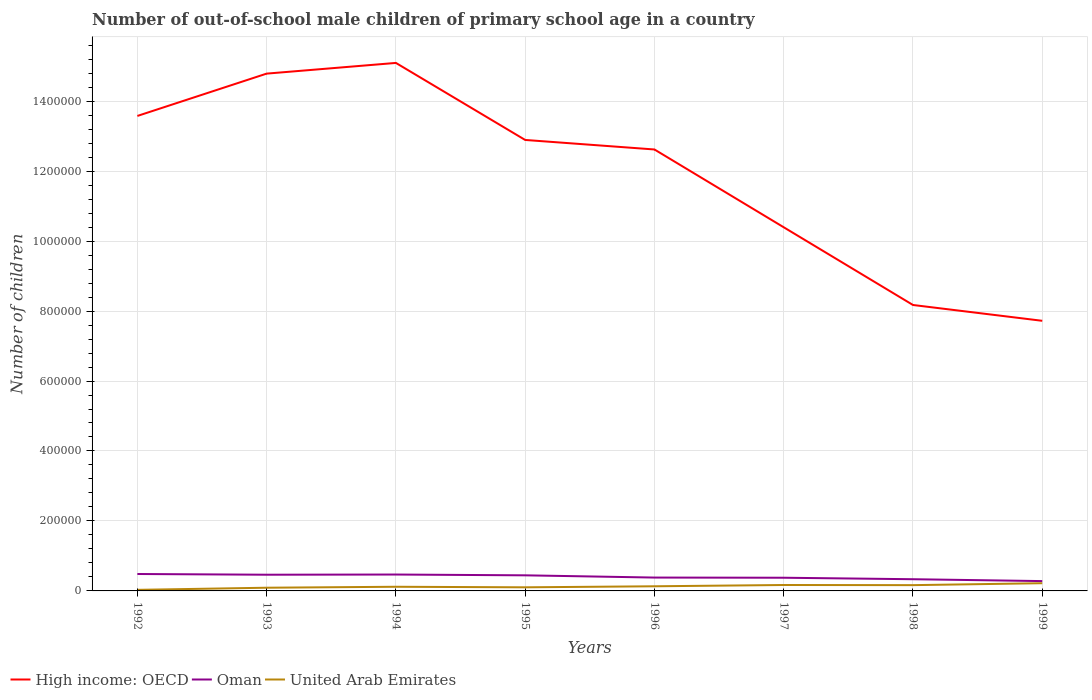How many different coloured lines are there?
Keep it short and to the point. 3. Across all years, what is the maximum number of out-of-school male children in United Arab Emirates?
Keep it short and to the point. 3090. In which year was the number of out-of-school male children in Oman maximum?
Keep it short and to the point. 1999. What is the total number of out-of-school male children in Oman in the graph?
Your response must be concise. -550. What is the difference between the highest and the second highest number of out-of-school male children in High income: OECD?
Offer a terse response. 7.37e+05. What is the difference between the highest and the lowest number of out-of-school male children in High income: OECD?
Your answer should be compact. 5. How many lines are there?
Keep it short and to the point. 3. How many years are there in the graph?
Ensure brevity in your answer.  8. What is the difference between two consecutive major ticks on the Y-axis?
Your answer should be compact. 2.00e+05. Are the values on the major ticks of Y-axis written in scientific E-notation?
Your answer should be compact. No. Where does the legend appear in the graph?
Provide a succinct answer. Bottom left. How many legend labels are there?
Offer a terse response. 3. What is the title of the graph?
Make the answer very short. Number of out-of-school male children of primary school age in a country. What is the label or title of the X-axis?
Your answer should be very brief. Years. What is the label or title of the Y-axis?
Offer a very short reply. Number of children. What is the Number of children of High income: OECD in 1992?
Your response must be concise. 1.36e+06. What is the Number of children of Oman in 1992?
Offer a very short reply. 4.84e+04. What is the Number of children in United Arab Emirates in 1992?
Provide a short and direct response. 3090. What is the Number of children in High income: OECD in 1993?
Offer a very short reply. 1.48e+06. What is the Number of children in Oman in 1993?
Ensure brevity in your answer.  4.63e+04. What is the Number of children of United Arab Emirates in 1993?
Your response must be concise. 9153. What is the Number of children of High income: OECD in 1994?
Give a very brief answer. 1.51e+06. What is the Number of children in Oman in 1994?
Keep it short and to the point. 4.69e+04. What is the Number of children in United Arab Emirates in 1994?
Provide a succinct answer. 1.19e+04. What is the Number of children in High income: OECD in 1995?
Your response must be concise. 1.29e+06. What is the Number of children of Oman in 1995?
Your answer should be compact. 4.46e+04. What is the Number of children of United Arab Emirates in 1995?
Keep it short and to the point. 1.03e+04. What is the Number of children in High income: OECD in 1996?
Offer a terse response. 1.26e+06. What is the Number of children in Oman in 1996?
Keep it short and to the point. 3.82e+04. What is the Number of children of United Arab Emirates in 1996?
Offer a terse response. 1.33e+04. What is the Number of children in High income: OECD in 1997?
Ensure brevity in your answer.  1.04e+06. What is the Number of children of Oman in 1997?
Provide a short and direct response. 3.77e+04. What is the Number of children of United Arab Emirates in 1997?
Your response must be concise. 1.69e+04. What is the Number of children of High income: OECD in 1998?
Provide a short and direct response. 8.17e+05. What is the Number of children in Oman in 1998?
Make the answer very short. 3.35e+04. What is the Number of children in United Arab Emirates in 1998?
Give a very brief answer. 1.65e+04. What is the Number of children of High income: OECD in 1999?
Provide a succinct answer. 7.72e+05. What is the Number of children in Oman in 1999?
Ensure brevity in your answer.  2.81e+04. What is the Number of children in United Arab Emirates in 1999?
Make the answer very short. 2.21e+04. Across all years, what is the maximum Number of children in High income: OECD?
Your answer should be compact. 1.51e+06. Across all years, what is the maximum Number of children of Oman?
Offer a terse response. 4.84e+04. Across all years, what is the maximum Number of children of United Arab Emirates?
Offer a very short reply. 2.21e+04. Across all years, what is the minimum Number of children of High income: OECD?
Ensure brevity in your answer.  7.72e+05. Across all years, what is the minimum Number of children in Oman?
Give a very brief answer. 2.81e+04. Across all years, what is the minimum Number of children of United Arab Emirates?
Your answer should be very brief. 3090. What is the total Number of children in High income: OECD in the graph?
Your answer should be very brief. 9.53e+06. What is the total Number of children in Oman in the graph?
Provide a short and direct response. 3.24e+05. What is the total Number of children of United Arab Emirates in the graph?
Give a very brief answer. 1.03e+05. What is the difference between the Number of children of High income: OECD in 1992 and that in 1993?
Provide a short and direct response. -1.21e+05. What is the difference between the Number of children in Oman in 1992 and that in 1993?
Ensure brevity in your answer.  2030. What is the difference between the Number of children of United Arab Emirates in 1992 and that in 1993?
Your answer should be compact. -6063. What is the difference between the Number of children in High income: OECD in 1992 and that in 1994?
Your response must be concise. -1.52e+05. What is the difference between the Number of children in Oman in 1992 and that in 1994?
Make the answer very short. 1480. What is the difference between the Number of children of United Arab Emirates in 1992 and that in 1994?
Your response must be concise. -8775. What is the difference between the Number of children of High income: OECD in 1992 and that in 1995?
Your answer should be very brief. 6.86e+04. What is the difference between the Number of children of Oman in 1992 and that in 1995?
Offer a terse response. 3775. What is the difference between the Number of children in United Arab Emirates in 1992 and that in 1995?
Provide a succinct answer. -7204. What is the difference between the Number of children in High income: OECD in 1992 and that in 1996?
Provide a short and direct response. 9.58e+04. What is the difference between the Number of children of Oman in 1992 and that in 1996?
Provide a short and direct response. 1.02e+04. What is the difference between the Number of children in United Arab Emirates in 1992 and that in 1996?
Your answer should be compact. -1.02e+04. What is the difference between the Number of children in High income: OECD in 1992 and that in 1997?
Your answer should be very brief. 3.18e+05. What is the difference between the Number of children in Oman in 1992 and that in 1997?
Your answer should be compact. 1.06e+04. What is the difference between the Number of children of United Arab Emirates in 1992 and that in 1997?
Make the answer very short. -1.38e+04. What is the difference between the Number of children in High income: OECD in 1992 and that in 1998?
Your response must be concise. 5.40e+05. What is the difference between the Number of children of Oman in 1992 and that in 1998?
Give a very brief answer. 1.49e+04. What is the difference between the Number of children in United Arab Emirates in 1992 and that in 1998?
Keep it short and to the point. -1.34e+04. What is the difference between the Number of children in High income: OECD in 1992 and that in 1999?
Give a very brief answer. 5.86e+05. What is the difference between the Number of children in Oman in 1992 and that in 1999?
Make the answer very short. 2.03e+04. What is the difference between the Number of children in United Arab Emirates in 1992 and that in 1999?
Your answer should be compact. -1.90e+04. What is the difference between the Number of children of High income: OECD in 1993 and that in 1994?
Your answer should be compact. -3.06e+04. What is the difference between the Number of children in Oman in 1993 and that in 1994?
Your response must be concise. -550. What is the difference between the Number of children in United Arab Emirates in 1993 and that in 1994?
Provide a short and direct response. -2712. What is the difference between the Number of children of High income: OECD in 1993 and that in 1995?
Your answer should be compact. 1.90e+05. What is the difference between the Number of children of Oman in 1993 and that in 1995?
Give a very brief answer. 1745. What is the difference between the Number of children of United Arab Emirates in 1993 and that in 1995?
Offer a very short reply. -1141. What is the difference between the Number of children in High income: OECD in 1993 and that in 1996?
Ensure brevity in your answer.  2.17e+05. What is the difference between the Number of children in Oman in 1993 and that in 1996?
Your answer should be compact. 8154. What is the difference between the Number of children of United Arab Emirates in 1993 and that in 1996?
Provide a short and direct response. -4112. What is the difference between the Number of children in High income: OECD in 1993 and that in 1997?
Give a very brief answer. 4.39e+05. What is the difference between the Number of children in Oman in 1993 and that in 1997?
Your response must be concise. 8606. What is the difference between the Number of children of United Arab Emirates in 1993 and that in 1997?
Your answer should be compact. -7762. What is the difference between the Number of children in High income: OECD in 1993 and that in 1998?
Make the answer very short. 6.61e+05. What is the difference between the Number of children in Oman in 1993 and that in 1998?
Ensure brevity in your answer.  1.29e+04. What is the difference between the Number of children in United Arab Emirates in 1993 and that in 1998?
Keep it short and to the point. -7359. What is the difference between the Number of children in High income: OECD in 1993 and that in 1999?
Provide a short and direct response. 7.07e+05. What is the difference between the Number of children of Oman in 1993 and that in 1999?
Ensure brevity in your answer.  1.82e+04. What is the difference between the Number of children of United Arab Emirates in 1993 and that in 1999?
Your response must be concise. -1.29e+04. What is the difference between the Number of children in High income: OECD in 1994 and that in 1995?
Provide a succinct answer. 2.20e+05. What is the difference between the Number of children in Oman in 1994 and that in 1995?
Provide a short and direct response. 2295. What is the difference between the Number of children in United Arab Emirates in 1994 and that in 1995?
Your answer should be compact. 1571. What is the difference between the Number of children in High income: OECD in 1994 and that in 1996?
Offer a terse response. 2.47e+05. What is the difference between the Number of children of Oman in 1994 and that in 1996?
Offer a terse response. 8704. What is the difference between the Number of children of United Arab Emirates in 1994 and that in 1996?
Your answer should be very brief. -1400. What is the difference between the Number of children in High income: OECD in 1994 and that in 1997?
Give a very brief answer. 4.70e+05. What is the difference between the Number of children in Oman in 1994 and that in 1997?
Offer a very short reply. 9156. What is the difference between the Number of children of United Arab Emirates in 1994 and that in 1997?
Give a very brief answer. -5050. What is the difference between the Number of children in High income: OECD in 1994 and that in 1998?
Offer a very short reply. 6.92e+05. What is the difference between the Number of children of Oman in 1994 and that in 1998?
Make the answer very short. 1.34e+04. What is the difference between the Number of children in United Arab Emirates in 1994 and that in 1998?
Provide a succinct answer. -4647. What is the difference between the Number of children of High income: OECD in 1994 and that in 1999?
Make the answer very short. 7.37e+05. What is the difference between the Number of children of Oman in 1994 and that in 1999?
Make the answer very short. 1.88e+04. What is the difference between the Number of children in United Arab Emirates in 1994 and that in 1999?
Provide a succinct answer. -1.02e+04. What is the difference between the Number of children of High income: OECD in 1995 and that in 1996?
Ensure brevity in your answer.  2.72e+04. What is the difference between the Number of children in Oman in 1995 and that in 1996?
Provide a succinct answer. 6409. What is the difference between the Number of children of United Arab Emirates in 1995 and that in 1996?
Keep it short and to the point. -2971. What is the difference between the Number of children in High income: OECD in 1995 and that in 1997?
Make the answer very short. 2.50e+05. What is the difference between the Number of children of Oman in 1995 and that in 1997?
Your answer should be very brief. 6861. What is the difference between the Number of children of United Arab Emirates in 1995 and that in 1997?
Provide a succinct answer. -6621. What is the difference between the Number of children in High income: OECD in 1995 and that in 1998?
Your answer should be compact. 4.72e+05. What is the difference between the Number of children of Oman in 1995 and that in 1998?
Your answer should be compact. 1.11e+04. What is the difference between the Number of children in United Arab Emirates in 1995 and that in 1998?
Keep it short and to the point. -6218. What is the difference between the Number of children of High income: OECD in 1995 and that in 1999?
Keep it short and to the point. 5.17e+05. What is the difference between the Number of children in Oman in 1995 and that in 1999?
Provide a succinct answer. 1.65e+04. What is the difference between the Number of children in United Arab Emirates in 1995 and that in 1999?
Make the answer very short. -1.18e+04. What is the difference between the Number of children of High income: OECD in 1996 and that in 1997?
Your answer should be compact. 2.22e+05. What is the difference between the Number of children in Oman in 1996 and that in 1997?
Make the answer very short. 452. What is the difference between the Number of children in United Arab Emirates in 1996 and that in 1997?
Offer a very short reply. -3650. What is the difference between the Number of children of High income: OECD in 1996 and that in 1998?
Provide a short and direct response. 4.45e+05. What is the difference between the Number of children of Oman in 1996 and that in 1998?
Make the answer very short. 4708. What is the difference between the Number of children in United Arab Emirates in 1996 and that in 1998?
Give a very brief answer. -3247. What is the difference between the Number of children in High income: OECD in 1996 and that in 1999?
Offer a terse response. 4.90e+05. What is the difference between the Number of children in Oman in 1996 and that in 1999?
Your answer should be very brief. 1.01e+04. What is the difference between the Number of children in United Arab Emirates in 1996 and that in 1999?
Your response must be concise. -8800. What is the difference between the Number of children in High income: OECD in 1997 and that in 1998?
Keep it short and to the point. 2.22e+05. What is the difference between the Number of children in Oman in 1997 and that in 1998?
Keep it short and to the point. 4256. What is the difference between the Number of children of United Arab Emirates in 1997 and that in 1998?
Offer a very short reply. 403. What is the difference between the Number of children of High income: OECD in 1997 and that in 1999?
Your answer should be very brief. 2.67e+05. What is the difference between the Number of children in Oman in 1997 and that in 1999?
Keep it short and to the point. 9633. What is the difference between the Number of children in United Arab Emirates in 1997 and that in 1999?
Keep it short and to the point. -5150. What is the difference between the Number of children of High income: OECD in 1998 and that in 1999?
Your response must be concise. 4.52e+04. What is the difference between the Number of children in Oman in 1998 and that in 1999?
Offer a terse response. 5377. What is the difference between the Number of children in United Arab Emirates in 1998 and that in 1999?
Give a very brief answer. -5553. What is the difference between the Number of children of High income: OECD in 1992 and the Number of children of Oman in 1993?
Provide a short and direct response. 1.31e+06. What is the difference between the Number of children in High income: OECD in 1992 and the Number of children in United Arab Emirates in 1993?
Provide a short and direct response. 1.35e+06. What is the difference between the Number of children in Oman in 1992 and the Number of children in United Arab Emirates in 1993?
Make the answer very short. 3.92e+04. What is the difference between the Number of children of High income: OECD in 1992 and the Number of children of Oman in 1994?
Give a very brief answer. 1.31e+06. What is the difference between the Number of children in High income: OECD in 1992 and the Number of children in United Arab Emirates in 1994?
Your answer should be very brief. 1.35e+06. What is the difference between the Number of children of Oman in 1992 and the Number of children of United Arab Emirates in 1994?
Make the answer very short. 3.65e+04. What is the difference between the Number of children in High income: OECD in 1992 and the Number of children in Oman in 1995?
Provide a succinct answer. 1.31e+06. What is the difference between the Number of children of High income: OECD in 1992 and the Number of children of United Arab Emirates in 1995?
Keep it short and to the point. 1.35e+06. What is the difference between the Number of children of Oman in 1992 and the Number of children of United Arab Emirates in 1995?
Your answer should be very brief. 3.81e+04. What is the difference between the Number of children in High income: OECD in 1992 and the Number of children in Oman in 1996?
Provide a short and direct response. 1.32e+06. What is the difference between the Number of children of High income: OECD in 1992 and the Number of children of United Arab Emirates in 1996?
Provide a succinct answer. 1.34e+06. What is the difference between the Number of children in Oman in 1992 and the Number of children in United Arab Emirates in 1996?
Keep it short and to the point. 3.51e+04. What is the difference between the Number of children of High income: OECD in 1992 and the Number of children of Oman in 1997?
Your answer should be compact. 1.32e+06. What is the difference between the Number of children in High income: OECD in 1992 and the Number of children in United Arab Emirates in 1997?
Your response must be concise. 1.34e+06. What is the difference between the Number of children in Oman in 1992 and the Number of children in United Arab Emirates in 1997?
Your answer should be very brief. 3.14e+04. What is the difference between the Number of children in High income: OECD in 1992 and the Number of children in Oman in 1998?
Offer a very short reply. 1.32e+06. What is the difference between the Number of children of High income: OECD in 1992 and the Number of children of United Arab Emirates in 1998?
Provide a succinct answer. 1.34e+06. What is the difference between the Number of children in Oman in 1992 and the Number of children in United Arab Emirates in 1998?
Offer a very short reply. 3.18e+04. What is the difference between the Number of children in High income: OECD in 1992 and the Number of children in Oman in 1999?
Offer a terse response. 1.33e+06. What is the difference between the Number of children in High income: OECD in 1992 and the Number of children in United Arab Emirates in 1999?
Your answer should be compact. 1.34e+06. What is the difference between the Number of children of Oman in 1992 and the Number of children of United Arab Emirates in 1999?
Make the answer very short. 2.63e+04. What is the difference between the Number of children in High income: OECD in 1993 and the Number of children in Oman in 1994?
Offer a terse response. 1.43e+06. What is the difference between the Number of children in High income: OECD in 1993 and the Number of children in United Arab Emirates in 1994?
Make the answer very short. 1.47e+06. What is the difference between the Number of children in Oman in 1993 and the Number of children in United Arab Emirates in 1994?
Your answer should be very brief. 3.45e+04. What is the difference between the Number of children of High income: OECD in 1993 and the Number of children of Oman in 1995?
Ensure brevity in your answer.  1.43e+06. What is the difference between the Number of children in High income: OECD in 1993 and the Number of children in United Arab Emirates in 1995?
Your answer should be compact. 1.47e+06. What is the difference between the Number of children of Oman in 1993 and the Number of children of United Arab Emirates in 1995?
Ensure brevity in your answer.  3.60e+04. What is the difference between the Number of children in High income: OECD in 1993 and the Number of children in Oman in 1996?
Give a very brief answer. 1.44e+06. What is the difference between the Number of children in High income: OECD in 1993 and the Number of children in United Arab Emirates in 1996?
Your answer should be very brief. 1.47e+06. What is the difference between the Number of children of Oman in 1993 and the Number of children of United Arab Emirates in 1996?
Provide a succinct answer. 3.31e+04. What is the difference between the Number of children of High income: OECD in 1993 and the Number of children of Oman in 1997?
Make the answer very short. 1.44e+06. What is the difference between the Number of children in High income: OECD in 1993 and the Number of children in United Arab Emirates in 1997?
Give a very brief answer. 1.46e+06. What is the difference between the Number of children in Oman in 1993 and the Number of children in United Arab Emirates in 1997?
Make the answer very short. 2.94e+04. What is the difference between the Number of children of High income: OECD in 1993 and the Number of children of Oman in 1998?
Ensure brevity in your answer.  1.45e+06. What is the difference between the Number of children in High income: OECD in 1993 and the Number of children in United Arab Emirates in 1998?
Offer a terse response. 1.46e+06. What is the difference between the Number of children of Oman in 1993 and the Number of children of United Arab Emirates in 1998?
Offer a terse response. 2.98e+04. What is the difference between the Number of children of High income: OECD in 1993 and the Number of children of Oman in 1999?
Your answer should be compact. 1.45e+06. What is the difference between the Number of children in High income: OECD in 1993 and the Number of children in United Arab Emirates in 1999?
Offer a terse response. 1.46e+06. What is the difference between the Number of children of Oman in 1993 and the Number of children of United Arab Emirates in 1999?
Keep it short and to the point. 2.43e+04. What is the difference between the Number of children in High income: OECD in 1994 and the Number of children in Oman in 1995?
Ensure brevity in your answer.  1.46e+06. What is the difference between the Number of children in High income: OECD in 1994 and the Number of children in United Arab Emirates in 1995?
Provide a short and direct response. 1.50e+06. What is the difference between the Number of children of Oman in 1994 and the Number of children of United Arab Emirates in 1995?
Make the answer very short. 3.66e+04. What is the difference between the Number of children of High income: OECD in 1994 and the Number of children of Oman in 1996?
Ensure brevity in your answer.  1.47e+06. What is the difference between the Number of children of High income: OECD in 1994 and the Number of children of United Arab Emirates in 1996?
Your answer should be compact. 1.50e+06. What is the difference between the Number of children in Oman in 1994 and the Number of children in United Arab Emirates in 1996?
Offer a terse response. 3.36e+04. What is the difference between the Number of children of High income: OECD in 1994 and the Number of children of Oman in 1997?
Your response must be concise. 1.47e+06. What is the difference between the Number of children in High income: OECD in 1994 and the Number of children in United Arab Emirates in 1997?
Your answer should be compact. 1.49e+06. What is the difference between the Number of children in Oman in 1994 and the Number of children in United Arab Emirates in 1997?
Provide a succinct answer. 3.00e+04. What is the difference between the Number of children of High income: OECD in 1994 and the Number of children of Oman in 1998?
Give a very brief answer. 1.48e+06. What is the difference between the Number of children in High income: OECD in 1994 and the Number of children in United Arab Emirates in 1998?
Your answer should be very brief. 1.49e+06. What is the difference between the Number of children in Oman in 1994 and the Number of children in United Arab Emirates in 1998?
Ensure brevity in your answer.  3.04e+04. What is the difference between the Number of children of High income: OECD in 1994 and the Number of children of Oman in 1999?
Ensure brevity in your answer.  1.48e+06. What is the difference between the Number of children in High income: OECD in 1994 and the Number of children in United Arab Emirates in 1999?
Provide a succinct answer. 1.49e+06. What is the difference between the Number of children in Oman in 1994 and the Number of children in United Arab Emirates in 1999?
Provide a succinct answer. 2.48e+04. What is the difference between the Number of children of High income: OECD in 1995 and the Number of children of Oman in 1996?
Give a very brief answer. 1.25e+06. What is the difference between the Number of children of High income: OECD in 1995 and the Number of children of United Arab Emirates in 1996?
Make the answer very short. 1.28e+06. What is the difference between the Number of children of Oman in 1995 and the Number of children of United Arab Emirates in 1996?
Give a very brief answer. 3.13e+04. What is the difference between the Number of children of High income: OECD in 1995 and the Number of children of Oman in 1997?
Your answer should be very brief. 1.25e+06. What is the difference between the Number of children in High income: OECD in 1995 and the Number of children in United Arab Emirates in 1997?
Provide a short and direct response. 1.27e+06. What is the difference between the Number of children in Oman in 1995 and the Number of children in United Arab Emirates in 1997?
Offer a terse response. 2.77e+04. What is the difference between the Number of children in High income: OECD in 1995 and the Number of children in Oman in 1998?
Offer a very short reply. 1.26e+06. What is the difference between the Number of children in High income: OECD in 1995 and the Number of children in United Arab Emirates in 1998?
Your answer should be compact. 1.27e+06. What is the difference between the Number of children in Oman in 1995 and the Number of children in United Arab Emirates in 1998?
Keep it short and to the point. 2.81e+04. What is the difference between the Number of children in High income: OECD in 1995 and the Number of children in Oman in 1999?
Make the answer very short. 1.26e+06. What is the difference between the Number of children in High income: OECD in 1995 and the Number of children in United Arab Emirates in 1999?
Offer a very short reply. 1.27e+06. What is the difference between the Number of children of Oman in 1995 and the Number of children of United Arab Emirates in 1999?
Offer a terse response. 2.25e+04. What is the difference between the Number of children in High income: OECD in 1996 and the Number of children in Oman in 1997?
Your answer should be very brief. 1.22e+06. What is the difference between the Number of children in High income: OECD in 1996 and the Number of children in United Arab Emirates in 1997?
Offer a very short reply. 1.24e+06. What is the difference between the Number of children in Oman in 1996 and the Number of children in United Arab Emirates in 1997?
Your response must be concise. 2.13e+04. What is the difference between the Number of children in High income: OECD in 1996 and the Number of children in Oman in 1998?
Make the answer very short. 1.23e+06. What is the difference between the Number of children of High income: OECD in 1996 and the Number of children of United Arab Emirates in 1998?
Keep it short and to the point. 1.25e+06. What is the difference between the Number of children of Oman in 1996 and the Number of children of United Arab Emirates in 1998?
Your answer should be compact. 2.17e+04. What is the difference between the Number of children in High income: OECD in 1996 and the Number of children in Oman in 1999?
Ensure brevity in your answer.  1.23e+06. What is the difference between the Number of children of High income: OECD in 1996 and the Number of children of United Arab Emirates in 1999?
Offer a very short reply. 1.24e+06. What is the difference between the Number of children of Oman in 1996 and the Number of children of United Arab Emirates in 1999?
Offer a terse response. 1.61e+04. What is the difference between the Number of children in High income: OECD in 1997 and the Number of children in Oman in 1998?
Offer a terse response. 1.01e+06. What is the difference between the Number of children in High income: OECD in 1997 and the Number of children in United Arab Emirates in 1998?
Offer a very short reply. 1.02e+06. What is the difference between the Number of children of Oman in 1997 and the Number of children of United Arab Emirates in 1998?
Provide a short and direct response. 2.12e+04. What is the difference between the Number of children of High income: OECD in 1997 and the Number of children of Oman in 1999?
Offer a terse response. 1.01e+06. What is the difference between the Number of children of High income: OECD in 1997 and the Number of children of United Arab Emirates in 1999?
Provide a succinct answer. 1.02e+06. What is the difference between the Number of children in Oman in 1997 and the Number of children in United Arab Emirates in 1999?
Provide a short and direct response. 1.57e+04. What is the difference between the Number of children in High income: OECD in 1998 and the Number of children in Oman in 1999?
Offer a very short reply. 7.89e+05. What is the difference between the Number of children of High income: OECD in 1998 and the Number of children of United Arab Emirates in 1999?
Your answer should be very brief. 7.95e+05. What is the difference between the Number of children in Oman in 1998 and the Number of children in United Arab Emirates in 1999?
Give a very brief answer. 1.14e+04. What is the average Number of children of High income: OECD per year?
Keep it short and to the point. 1.19e+06. What is the average Number of children of Oman per year?
Offer a terse response. 4.04e+04. What is the average Number of children of United Arab Emirates per year?
Your answer should be very brief. 1.29e+04. In the year 1992, what is the difference between the Number of children of High income: OECD and Number of children of Oman?
Your answer should be very brief. 1.31e+06. In the year 1992, what is the difference between the Number of children of High income: OECD and Number of children of United Arab Emirates?
Make the answer very short. 1.35e+06. In the year 1992, what is the difference between the Number of children of Oman and Number of children of United Arab Emirates?
Offer a terse response. 4.53e+04. In the year 1993, what is the difference between the Number of children in High income: OECD and Number of children in Oman?
Your response must be concise. 1.43e+06. In the year 1993, what is the difference between the Number of children of High income: OECD and Number of children of United Arab Emirates?
Your answer should be very brief. 1.47e+06. In the year 1993, what is the difference between the Number of children of Oman and Number of children of United Arab Emirates?
Provide a succinct answer. 3.72e+04. In the year 1994, what is the difference between the Number of children in High income: OECD and Number of children in Oman?
Your answer should be compact. 1.46e+06. In the year 1994, what is the difference between the Number of children in High income: OECD and Number of children in United Arab Emirates?
Make the answer very short. 1.50e+06. In the year 1994, what is the difference between the Number of children in Oman and Number of children in United Arab Emirates?
Your response must be concise. 3.50e+04. In the year 1995, what is the difference between the Number of children in High income: OECD and Number of children in Oman?
Your response must be concise. 1.24e+06. In the year 1995, what is the difference between the Number of children of High income: OECD and Number of children of United Arab Emirates?
Keep it short and to the point. 1.28e+06. In the year 1995, what is the difference between the Number of children in Oman and Number of children in United Arab Emirates?
Give a very brief answer. 3.43e+04. In the year 1996, what is the difference between the Number of children in High income: OECD and Number of children in Oman?
Provide a short and direct response. 1.22e+06. In the year 1996, what is the difference between the Number of children in High income: OECD and Number of children in United Arab Emirates?
Your answer should be very brief. 1.25e+06. In the year 1996, what is the difference between the Number of children of Oman and Number of children of United Arab Emirates?
Offer a very short reply. 2.49e+04. In the year 1997, what is the difference between the Number of children in High income: OECD and Number of children in Oman?
Your answer should be very brief. 1.00e+06. In the year 1997, what is the difference between the Number of children in High income: OECD and Number of children in United Arab Emirates?
Offer a very short reply. 1.02e+06. In the year 1997, what is the difference between the Number of children of Oman and Number of children of United Arab Emirates?
Offer a very short reply. 2.08e+04. In the year 1998, what is the difference between the Number of children in High income: OECD and Number of children in Oman?
Give a very brief answer. 7.84e+05. In the year 1998, what is the difference between the Number of children in High income: OECD and Number of children in United Arab Emirates?
Offer a very short reply. 8.01e+05. In the year 1998, what is the difference between the Number of children of Oman and Number of children of United Arab Emirates?
Offer a terse response. 1.69e+04. In the year 1999, what is the difference between the Number of children in High income: OECD and Number of children in Oman?
Provide a short and direct response. 7.44e+05. In the year 1999, what is the difference between the Number of children of High income: OECD and Number of children of United Arab Emirates?
Offer a very short reply. 7.50e+05. In the year 1999, what is the difference between the Number of children of Oman and Number of children of United Arab Emirates?
Make the answer very short. 6018. What is the ratio of the Number of children of High income: OECD in 1992 to that in 1993?
Your answer should be compact. 0.92. What is the ratio of the Number of children in Oman in 1992 to that in 1993?
Offer a very short reply. 1.04. What is the ratio of the Number of children in United Arab Emirates in 1992 to that in 1993?
Offer a very short reply. 0.34. What is the ratio of the Number of children in High income: OECD in 1992 to that in 1994?
Provide a succinct answer. 0.9. What is the ratio of the Number of children in Oman in 1992 to that in 1994?
Keep it short and to the point. 1.03. What is the ratio of the Number of children in United Arab Emirates in 1992 to that in 1994?
Your answer should be compact. 0.26. What is the ratio of the Number of children of High income: OECD in 1992 to that in 1995?
Make the answer very short. 1.05. What is the ratio of the Number of children in Oman in 1992 to that in 1995?
Your answer should be very brief. 1.08. What is the ratio of the Number of children in United Arab Emirates in 1992 to that in 1995?
Keep it short and to the point. 0.3. What is the ratio of the Number of children of High income: OECD in 1992 to that in 1996?
Offer a very short reply. 1.08. What is the ratio of the Number of children of Oman in 1992 to that in 1996?
Provide a succinct answer. 1.27. What is the ratio of the Number of children of United Arab Emirates in 1992 to that in 1996?
Provide a short and direct response. 0.23. What is the ratio of the Number of children of High income: OECD in 1992 to that in 1997?
Offer a terse response. 1.31. What is the ratio of the Number of children of Oman in 1992 to that in 1997?
Your answer should be very brief. 1.28. What is the ratio of the Number of children of United Arab Emirates in 1992 to that in 1997?
Your response must be concise. 0.18. What is the ratio of the Number of children of High income: OECD in 1992 to that in 1998?
Your answer should be compact. 1.66. What is the ratio of the Number of children in Oman in 1992 to that in 1998?
Provide a succinct answer. 1.45. What is the ratio of the Number of children in United Arab Emirates in 1992 to that in 1998?
Ensure brevity in your answer.  0.19. What is the ratio of the Number of children in High income: OECD in 1992 to that in 1999?
Offer a very short reply. 1.76. What is the ratio of the Number of children of Oman in 1992 to that in 1999?
Keep it short and to the point. 1.72. What is the ratio of the Number of children in United Arab Emirates in 1992 to that in 1999?
Give a very brief answer. 0.14. What is the ratio of the Number of children of High income: OECD in 1993 to that in 1994?
Provide a succinct answer. 0.98. What is the ratio of the Number of children in Oman in 1993 to that in 1994?
Make the answer very short. 0.99. What is the ratio of the Number of children in United Arab Emirates in 1993 to that in 1994?
Make the answer very short. 0.77. What is the ratio of the Number of children in High income: OECD in 1993 to that in 1995?
Your answer should be very brief. 1.15. What is the ratio of the Number of children in Oman in 1993 to that in 1995?
Your answer should be compact. 1.04. What is the ratio of the Number of children in United Arab Emirates in 1993 to that in 1995?
Keep it short and to the point. 0.89. What is the ratio of the Number of children of High income: OECD in 1993 to that in 1996?
Keep it short and to the point. 1.17. What is the ratio of the Number of children of Oman in 1993 to that in 1996?
Your answer should be very brief. 1.21. What is the ratio of the Number of children in United Arab Emirates in 1993 to that in 1996?
Provide a succinct answer. 0.69. What is the ratio of the Number of children of High income: OECD in 1993 to that in 1997?
Provide a short and direct response. 1.42. What is the ratio of the Number of children in Oman in 1993 to that in 1997?
Your answer should be very brief. 1.23. What is the ratio of the Number of children in United Arab Emirates in 1993 to that in 1997?
Your answer should be compact. 0.54. What is the ratio of the Number of children in High income: OECD in 1993 to that in 1998?
Provide a short and direct response. 1.81. What is the ratio of the Number of children of Oman in 1993 to that in 1998?
Offer a very short reply. 1.38. What is the ratio of the Number of children of United Arab Emirates in 1993 to that in 1998?
Your answer should be compact. 0.55. What is the ratio of the Number of children in High income: OECD in 1993 to that in 1999?
Provide a succinct answer. 1.92. What is the ratio of the Number of children in Oman in 1993 to that in 1999?
Ensure brevity in your answer.  1.65. What is the ratio of the Number of children in United Arab Emirates in 1993 to that in 1999?
Your answer should be very brief. 0.41. What is the ratio of the Number of children in High income: OECD in 1994 to that in 1995?
Offer a very short reply. 1.17. What is the ratio of the Number of children in Oman in 1994 to that in 1995?
Provide a short and direct response. 1.05. What is the ratio of the Number of children in United Arab Emirates in 1994 to that in 1995?
Provide a short and direct response. 1.15. What is the ratio of the Number of children in High income: OECD in 1994 to that in 1996?
Provide a short and direct response. 1.2. What is the ratio of the Number of children in Oman in 1994 to that in 1996?
Your answer should be very brief. 1.23. What is the ratio of the Number of children in United Arab Emirates in 1994 to that in 1996?
Your response must be concise. 0.89. What is the ratio of the Number of children in High income: OECD in 1994 to that in 1997?
Ensure brevity in your answer.  1.45. What is the ratio of the Number of children in Oman in 1994 to that in 1997?
Ensure brevity in your answer.  1.24. What is the ratio of the Number of children of United Arab Emirates in 1994 to that in 1997?
Offer a terse response. 0.7. What is the ratio of the Number of children of High income: OECD in 1994 to that in 1998?
Keep it short and to the point. 1.85. What is the ratio of the Number of children of Oman in 1994 to that in 1998?
Keep it short and to the point. 1.4. What is the ratio of the Number of children in United Arab Emirates in 1994 to that in 1998?
Ensure brevity in your answer.  0.72. What is the ratio of the Number of children of High income: OECD in 1994 to that in 1999?
Provide a short and direct response. 1.95. What is the ratio of the Number of children in Oman in 1994 to that in 1999?
Your response must be concise. 1.67. What is the ratio of the Number of children in United Arab Emirates in 1994 to that in 1999?
Provide a short and direct response. 0.54. What is the ratio of the Number of children of High income: OECD in 1995 to that in 1996?
Ensure brevity in your answer.  1.02. What is the ratio of the Number of children in Oman in 1995 to that in 1996?
Ensure brevity in your answer.  1.17. What is the ratio of the Number of children of United Arab Emirates in 1995 to that in 1996?
Offer a terse response. 0.78. What is the ratio of the Number of children of High income: OECD in 1995 to that in 1997?
Give a very brief answer. 1.24. What is the ratio of the Number of children of Oman in 1995 to that in 1997?
Your answer should be very brief. 1.18. What is the ratio of the Number of children of United Arab Emirates in 1995 to that in 1997?
Ensure brevity in your answer.  0.61. What is the ratio of the Number of children in High income: OECD in 1995 to that in 1998?
Ensure brevity in your answer.  1.58. What is the ratio of the Number of children of Oman in 1995 to that in 1998?
Make the answer very short. 1.33. What is the ratio of the Number of children in United Arab Emirates in 1995 to that in 1998?
Provide a short and direct response. 0.62. What is the ratio of the Number of children of High income: OECD in 1995 to that in 1999?
Keep it short and to the point. 1.67. What is the ratio of the Number of children of Oman in 1995 to that in 1999?
Your answer should be very brief. 1.59. What is the ratio of the Number of children of United Arab Emirates in 1995 to that in 1999?
Give a very brief answer. 0.47. What is the ratio of the Number of children of High income: OECD in 1996 to that in 1997?
Your answer should be very brief. 1.21. What is the ratio of the Number of children in Oman in 1996 to that in 1997?
Give a very brief answer. 1.01. What is the ratio of the Number of children in United Arab Emirates in 1996 to that in 1997?
Give a very brief answer. 0.78. What is the ratio of the Number of children of High income: OECD in 1996 to that in 1998?
Give a very brief answer. 1.54. What is the ratio of the Number of children of Oman in 1996 to that in 1998?
Your answer should be compact. 1.14. What is the ratio of the Number of children of United Arab Emirates in 1996 to that in 1998?
Your answer should be very brief. 0.8. What is the ratio of the Number of children in High income: OECD in 1996 to that in 1999?
Provide a succinct answer. 1.63. What is the ratio of the Number of children in Oman in 1996 to that in 1999?
Ensure brevity in your answer.  1.36. What is the ratio of the Number of children in United Arab Emirates in 1996 to that in 1999?
Keep it short and to the point. 0.6. What is the ratio of the Number of children of High income: OECD in 1997 to that in 1998?
Give a very brief answer. 1.27. What is the ratio of the Number of children of Oman in 1997 to that in 1998?
Your response must be concise. 1.13. What is the ratio of the Number of children of United Arab Emirates in 1997 to that in 1998?
Offer a terse response. 1.02. What is the ratio of the Number of children in High income: OECD in 1997 to that in 1999?
Ensure brevity in your answer.  1.35. What is the ratio of the Number of children of Oman in 1997 to that in 1999?
Make the answer very short. 1.34. What is the ratio of the Number of children in United Arab Emirates in 1997 to that in 1999?
Ensure brevity in your answer.  0.77. What is the ratio of the Number of children of High income: OECD in 1998 to that in 1999?
Offer a terse response. 1.06. What is the ratio of the Number of children in Oman in 1998 to that in 1999?
Ensure brevity in your answer.  1.19. What is the ratio of the Number of children in United Arab Emirates in 1998 to that in 1999?
Provide a succinct answer. 0.75. What is the difference between the highest and the second highest Number of children in High income: OECD?
Your answer should be compact. 3.06e+04. What is the difference between the highest and the second highest Number of children in Oman?
Your response must be concise. 1480. What is the difference between the highest and the second highest Number of children of United Arab Emirates?
Offer a terse response. 5150. What is the difference between the highest and the lowest Number of children in High income: OECD?
Your answer should be compact. 7.37e+05. What is the difference between the highest and the lowest Number of children of Oman?
Keep it short and to the point. 2.03e+04. What is the difference between the highest and the lowest Number of children of United Arab Emirates?
Offer a terse response. 1.90e+04. 